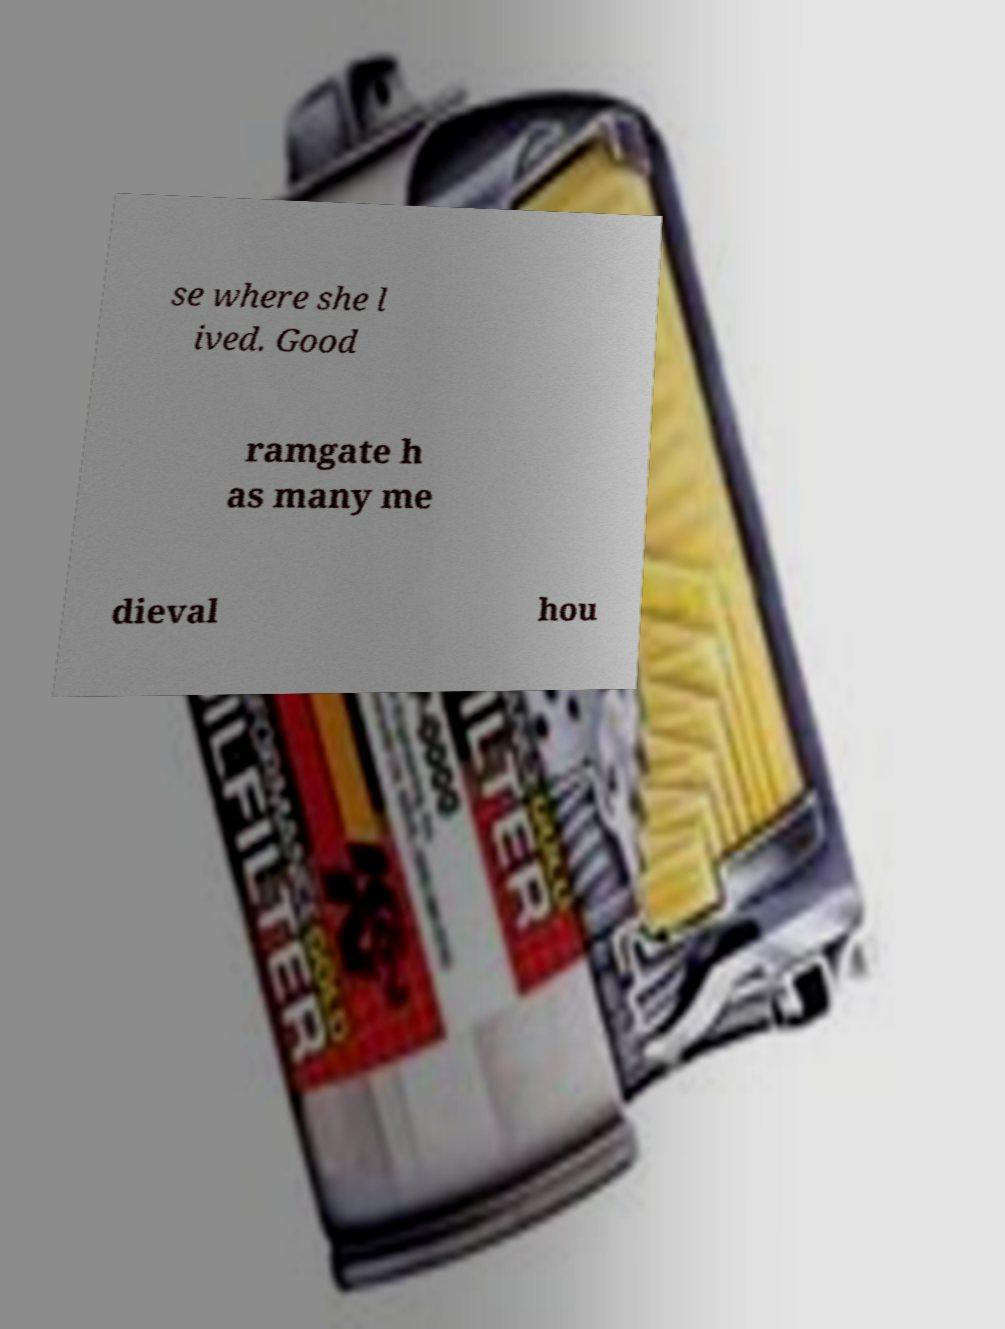Can you accurately transcribe the text from the provided image for me? se where she l ived. Good ramgate h as many me dieval hou 